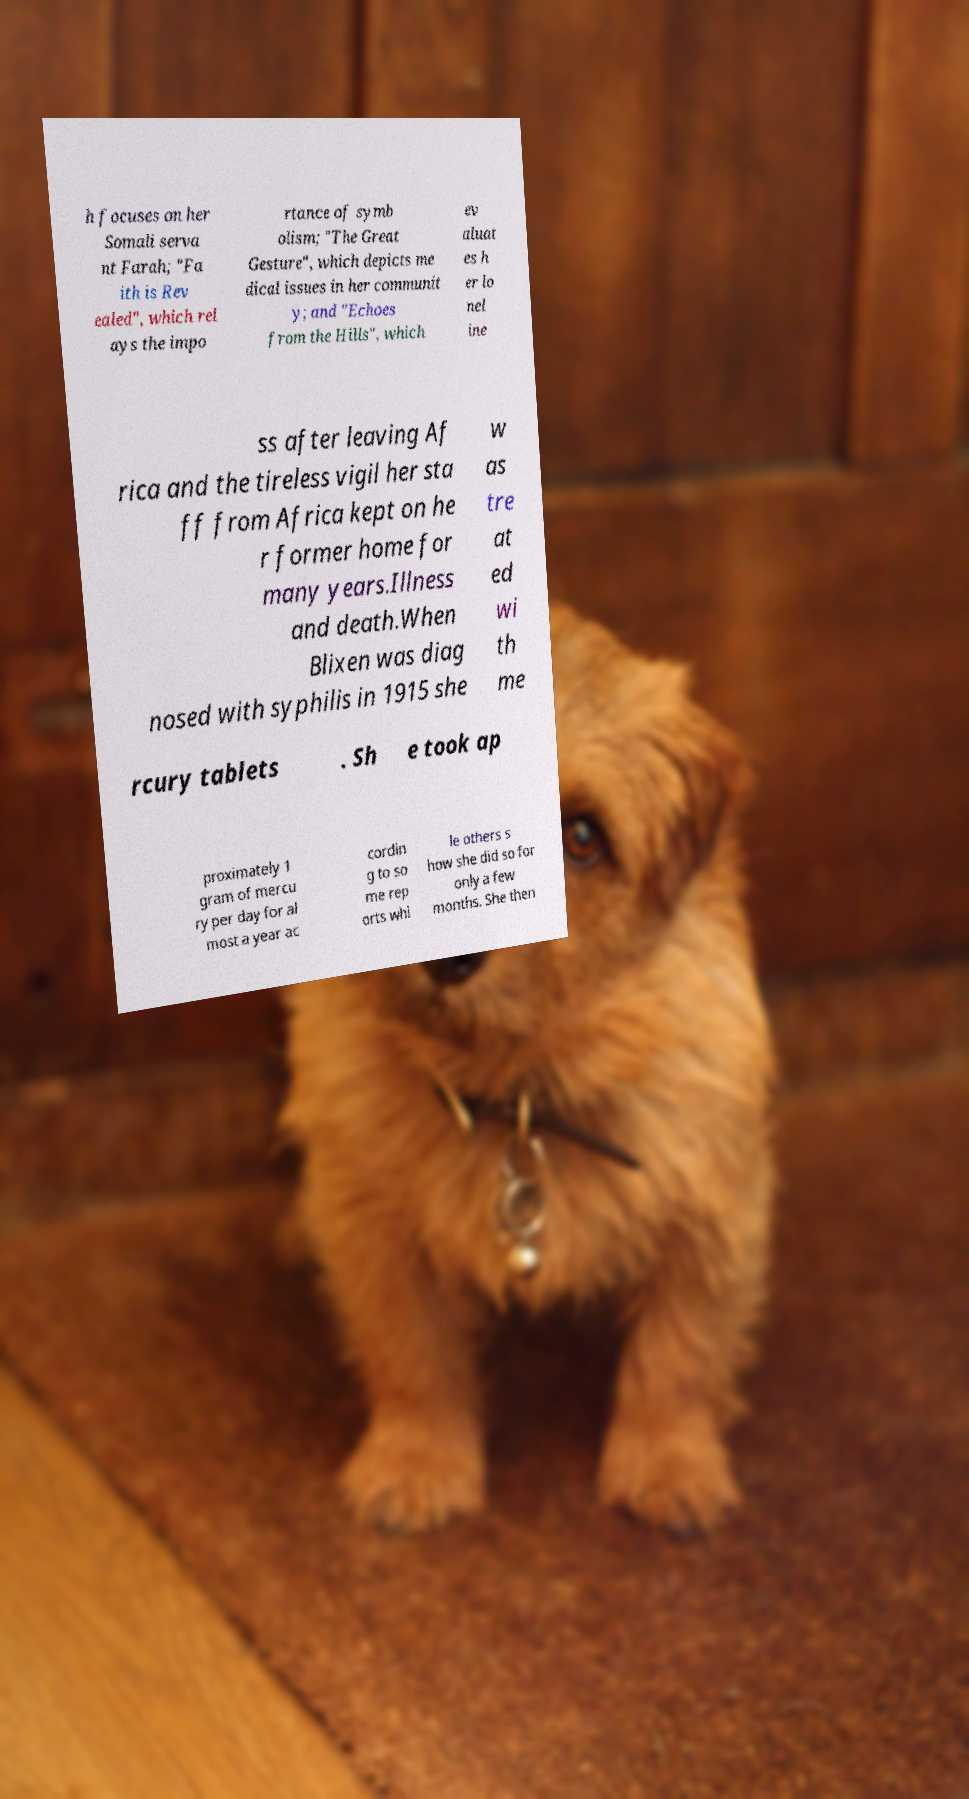There's text embedded in this image that I need extracted. Can you transcribe it verbatim? h focuses on her Somali serva nt Farah; "Fa ith is Rev ealed", which rel ays the impo rtance of symb olism; "The Great Gesture", which depicts me dical issues in her communit y; and "Echoes from the Hills", which ev aluat es h er lo nel ine ss after leaving Af rica and the tireless vigil her sta ff from Africa kept on he r former home for many years.Illness and death.When Blixen was diag nosed with syphilis in 1915 she w as tre at ed wi th me rcury tablets . Sh e took ap proximately 1 gram of mercu ry per day for al most a year ac cordin g to so me rep orts whi le others s how she did so for only a few months. She then 